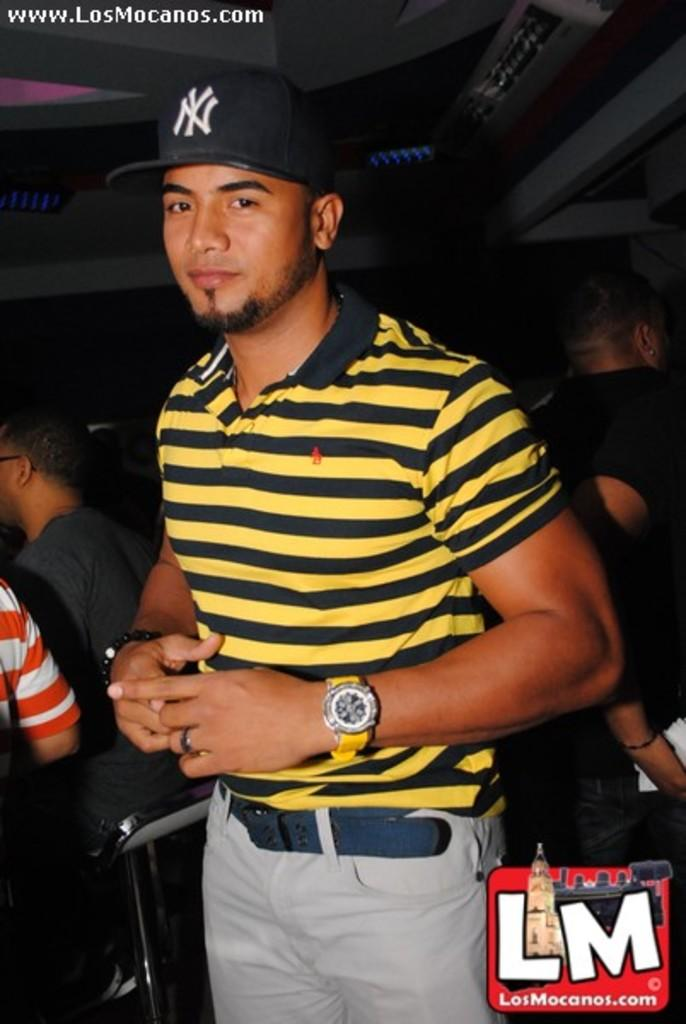What is the main subject of the image? The main subject of the image is a man. Can you describe the man's clothing in the image? The man is wearing a yellow T-shirt with black lines and a black cap. Are there any other people in the image? Yes, there are people standing behind the man. What can be observed about the background of the image? The background of the image is dark. What time of day is it in the image, based on the hour displayed on the man's wristwatch? There is no wristwatch visible in the image, so we cannot determine the time of day based on an hour display. How many feet are visible in the image? The image does not show any feet; it primarily focuses on the man and the people behind him. 